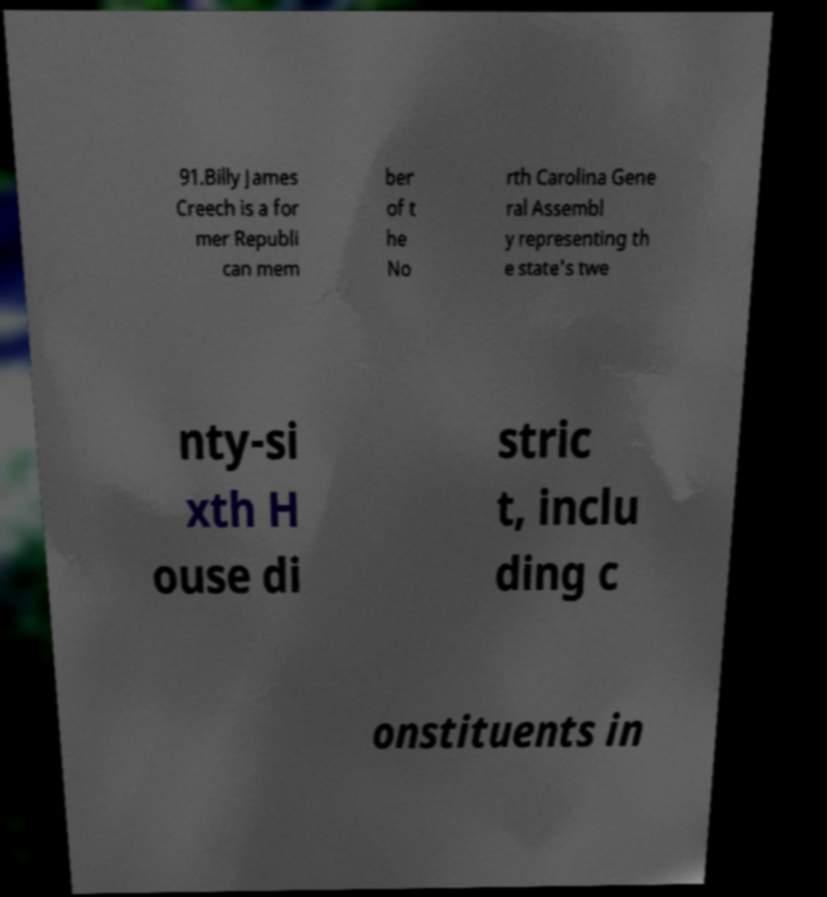I need the written content from this picture converted into text. Can you do that? 91.Billy James Creech is a for mer Republi can mem ber of t he No rth Carolina Gene ral Assembl y representing th e state's twe nty-si xth H ouse di stric t, inclu ding c onstituents in 